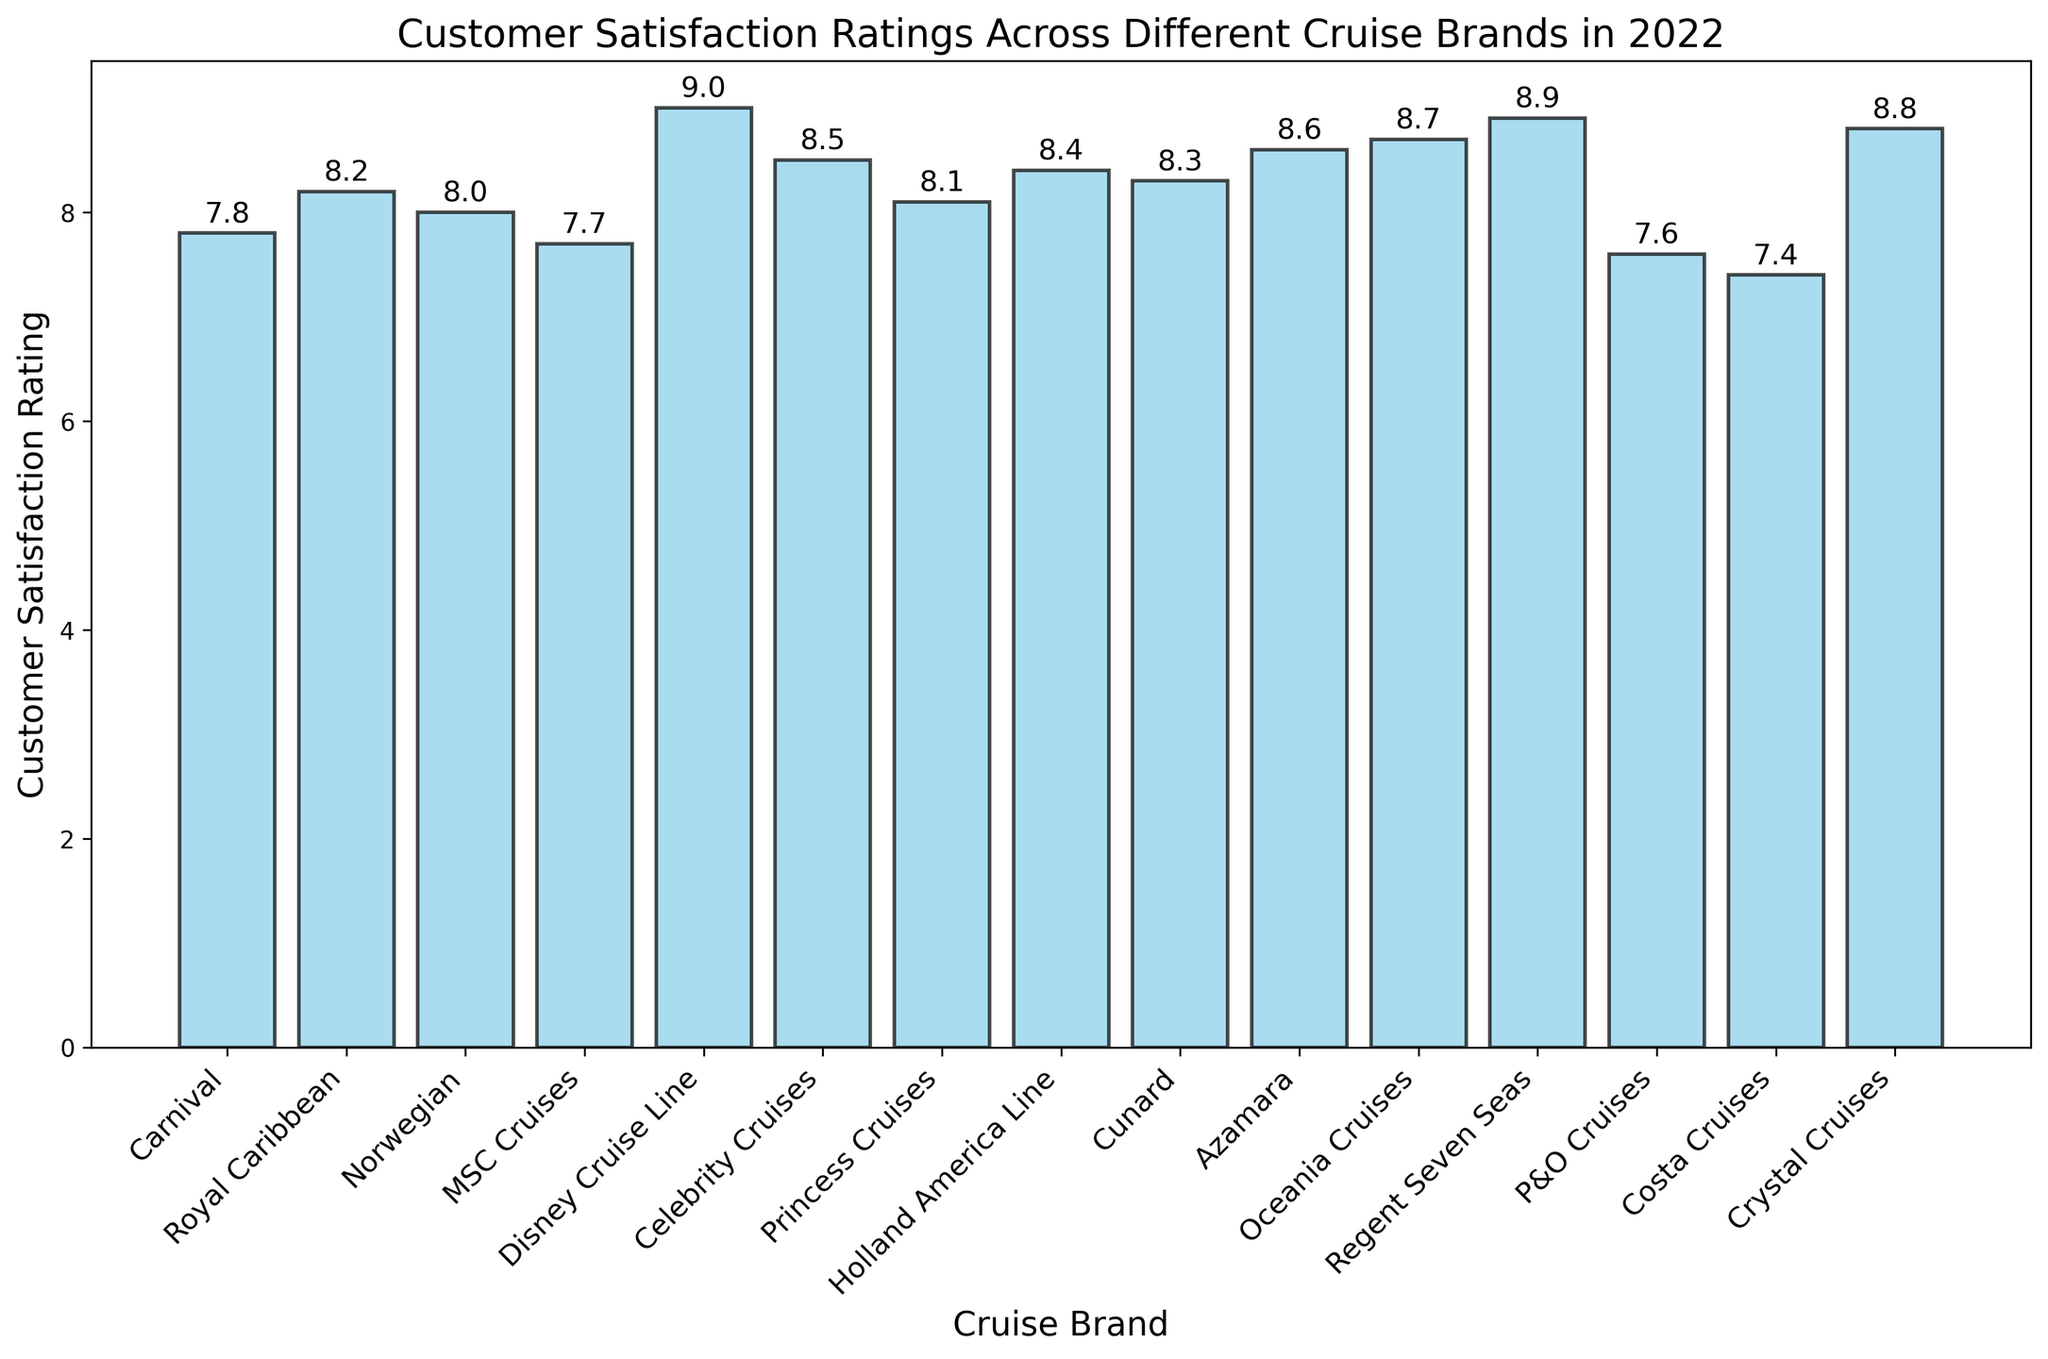What's the highest customer satisfaction rating among the cruise brands? Look at the tallest bar in the chart, which corresponds to Disney Cruise Line with a rating of 9.0
Answer: 9.0 Which cruise brand has the lowest customer satisfaction rating? Identify the shortest bar in the chart, which belongs to Costa Cruises with a rating of 7.4
Answer: Costa Cruises What is the difference in customer satisfaction ratings between Norwegian and Carnival? Find the bar heights for Norwegian (8.0) and Carnival (7.8). Subtract the smaller rating from the larger rating, giving 8.0 - 7.8 = 0.2
Answer: 0.2 Which cruise brands have ratings greater than 8.5? Scan for bars higher than the 8.5 line, identifying Azamara (8.6), Oceania Cruises (8.7), Crystal Cruises (8.8), and Regent Seven Seas (8.9)
Answer: Azamara, Oceania Cruises, Crystal Cruises, Regent Seven Seas What is the average customer satisfaction rating of MSC Cruises, Princess Cruises, and Cunard? Identify the ratings (MSC Cruises: 7.7, Princess Cruises: 8.1, Cunard: 8.3). Sum these values (7.7 + 8.1 + 8.3 = 24.1) and divide by 3 to get the average, which is 24.1 / 3 ≈ 8.03
Answer: 8.03 Which cruise brand has the second highest customer satisfaction rating? Identify the two tallest bars. Disney Cruise Line is highest (9.0). Regent Seven Seas is second highest (8.9)
Answer: Regent Seven Seas What is the total customer satisfaction rating for all cruise brands? Sum all individual ratings (7.8 + 8.2 + 8.0 + 7.7 + 9.0 + 8.5 + 8.1 + 8.4 + 8.3 + 8.6 + 8.7 + 8.9 + 7.6 + 7.4 + 8.8) = 125.0
Answer: 125.0 How many cruise brands have a customer satisfaction rating less than 8? Count the bars with heights less than 8. These are Carnival (7.8), MSC Cruises (7.7), P&O Cruises (7.6), and Costa Cruises (7.4), totaling 4 brands
Answer: 4 Which cruise brand has a higher customer satisfaction rating: Royal Caribbean or Celebrity Cruises? Compare the bar heights for Royal Caribbean (8.2) and Celebrity Cruises (8.5). Celebrity Cruises has the higher rating
Answer: Celebrity Cruises Is Oceania Cruises' customer satisfaction rating higher than the average rating of all cruise brands? Calculate the total rating of all brands (125.0) and divide by the number of brands (15) to get the average rating, which is 125.0 / 15 ≈ 8.33. Oceania Cruises has a rating of 8.7, which is higher
Answer: Yes, Oceania Cruises has a higher rating 